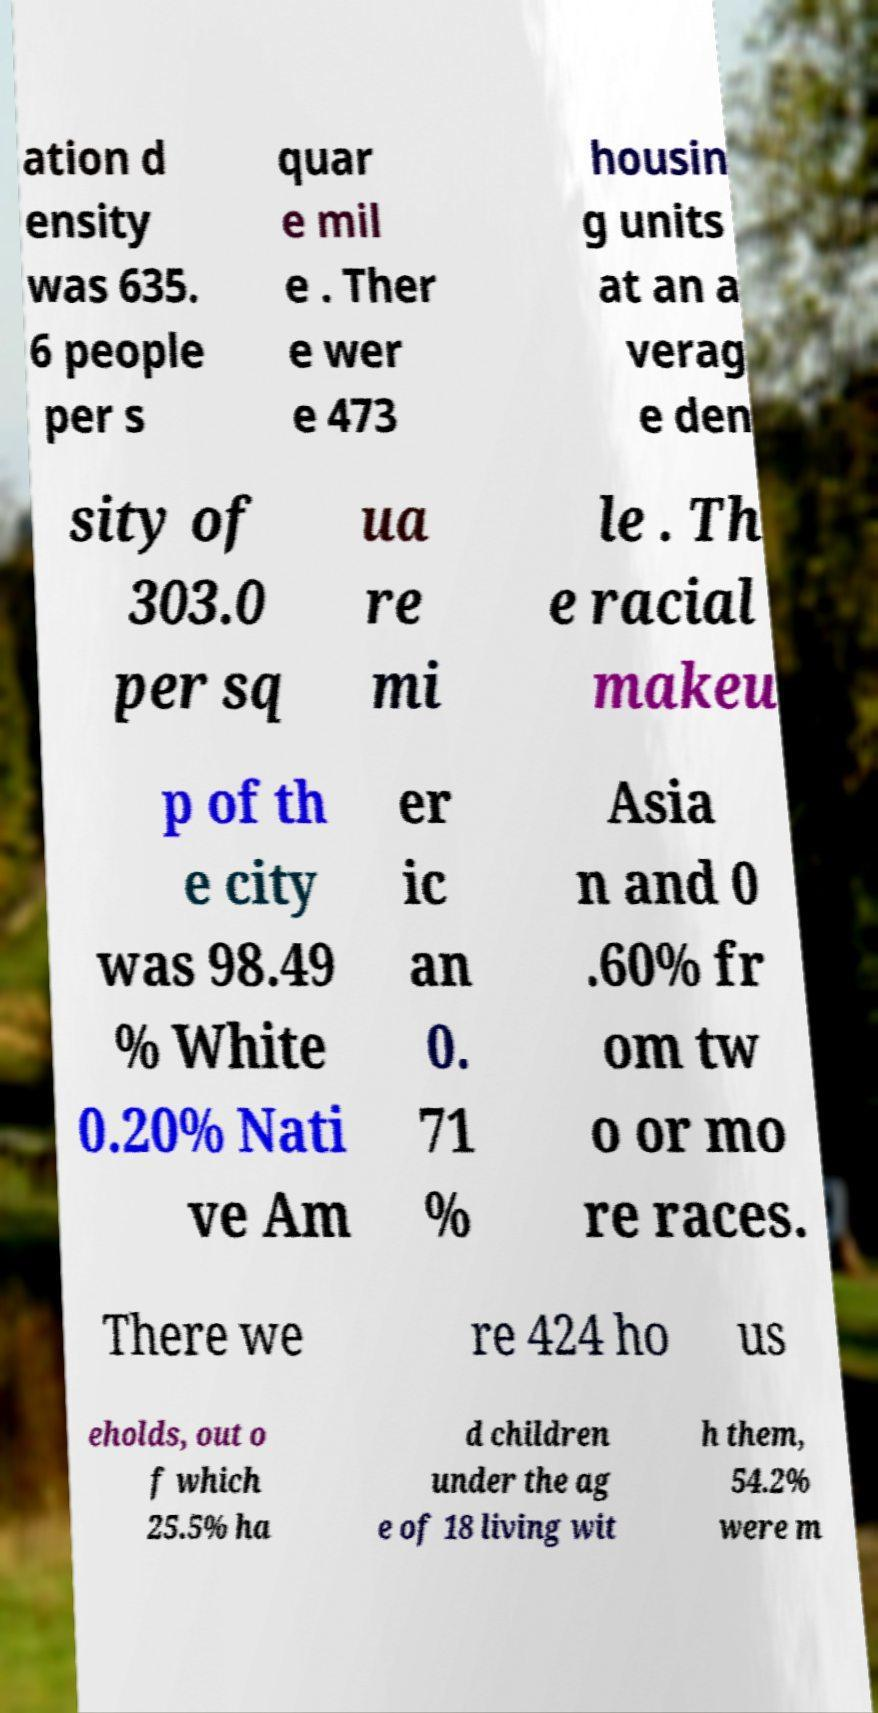Could you extract and type out the text from this image? ation d ensity was 635. 6 people per s quar e mil e . Ther e wer e 473 housin g units at an a verag e den sity of 303.0 per sq ua re mi le . Th e racial makeu p of th e city was 98.49 % White 0.20% Nati ve Am er ic an 0. 71 % Asia n and 0 .60% fr om tw o or mo re races. There we re 424 ho us eholds, out o f which 25.5% ha d children under the ag e of 18 living wit h them, 54.2% were m 